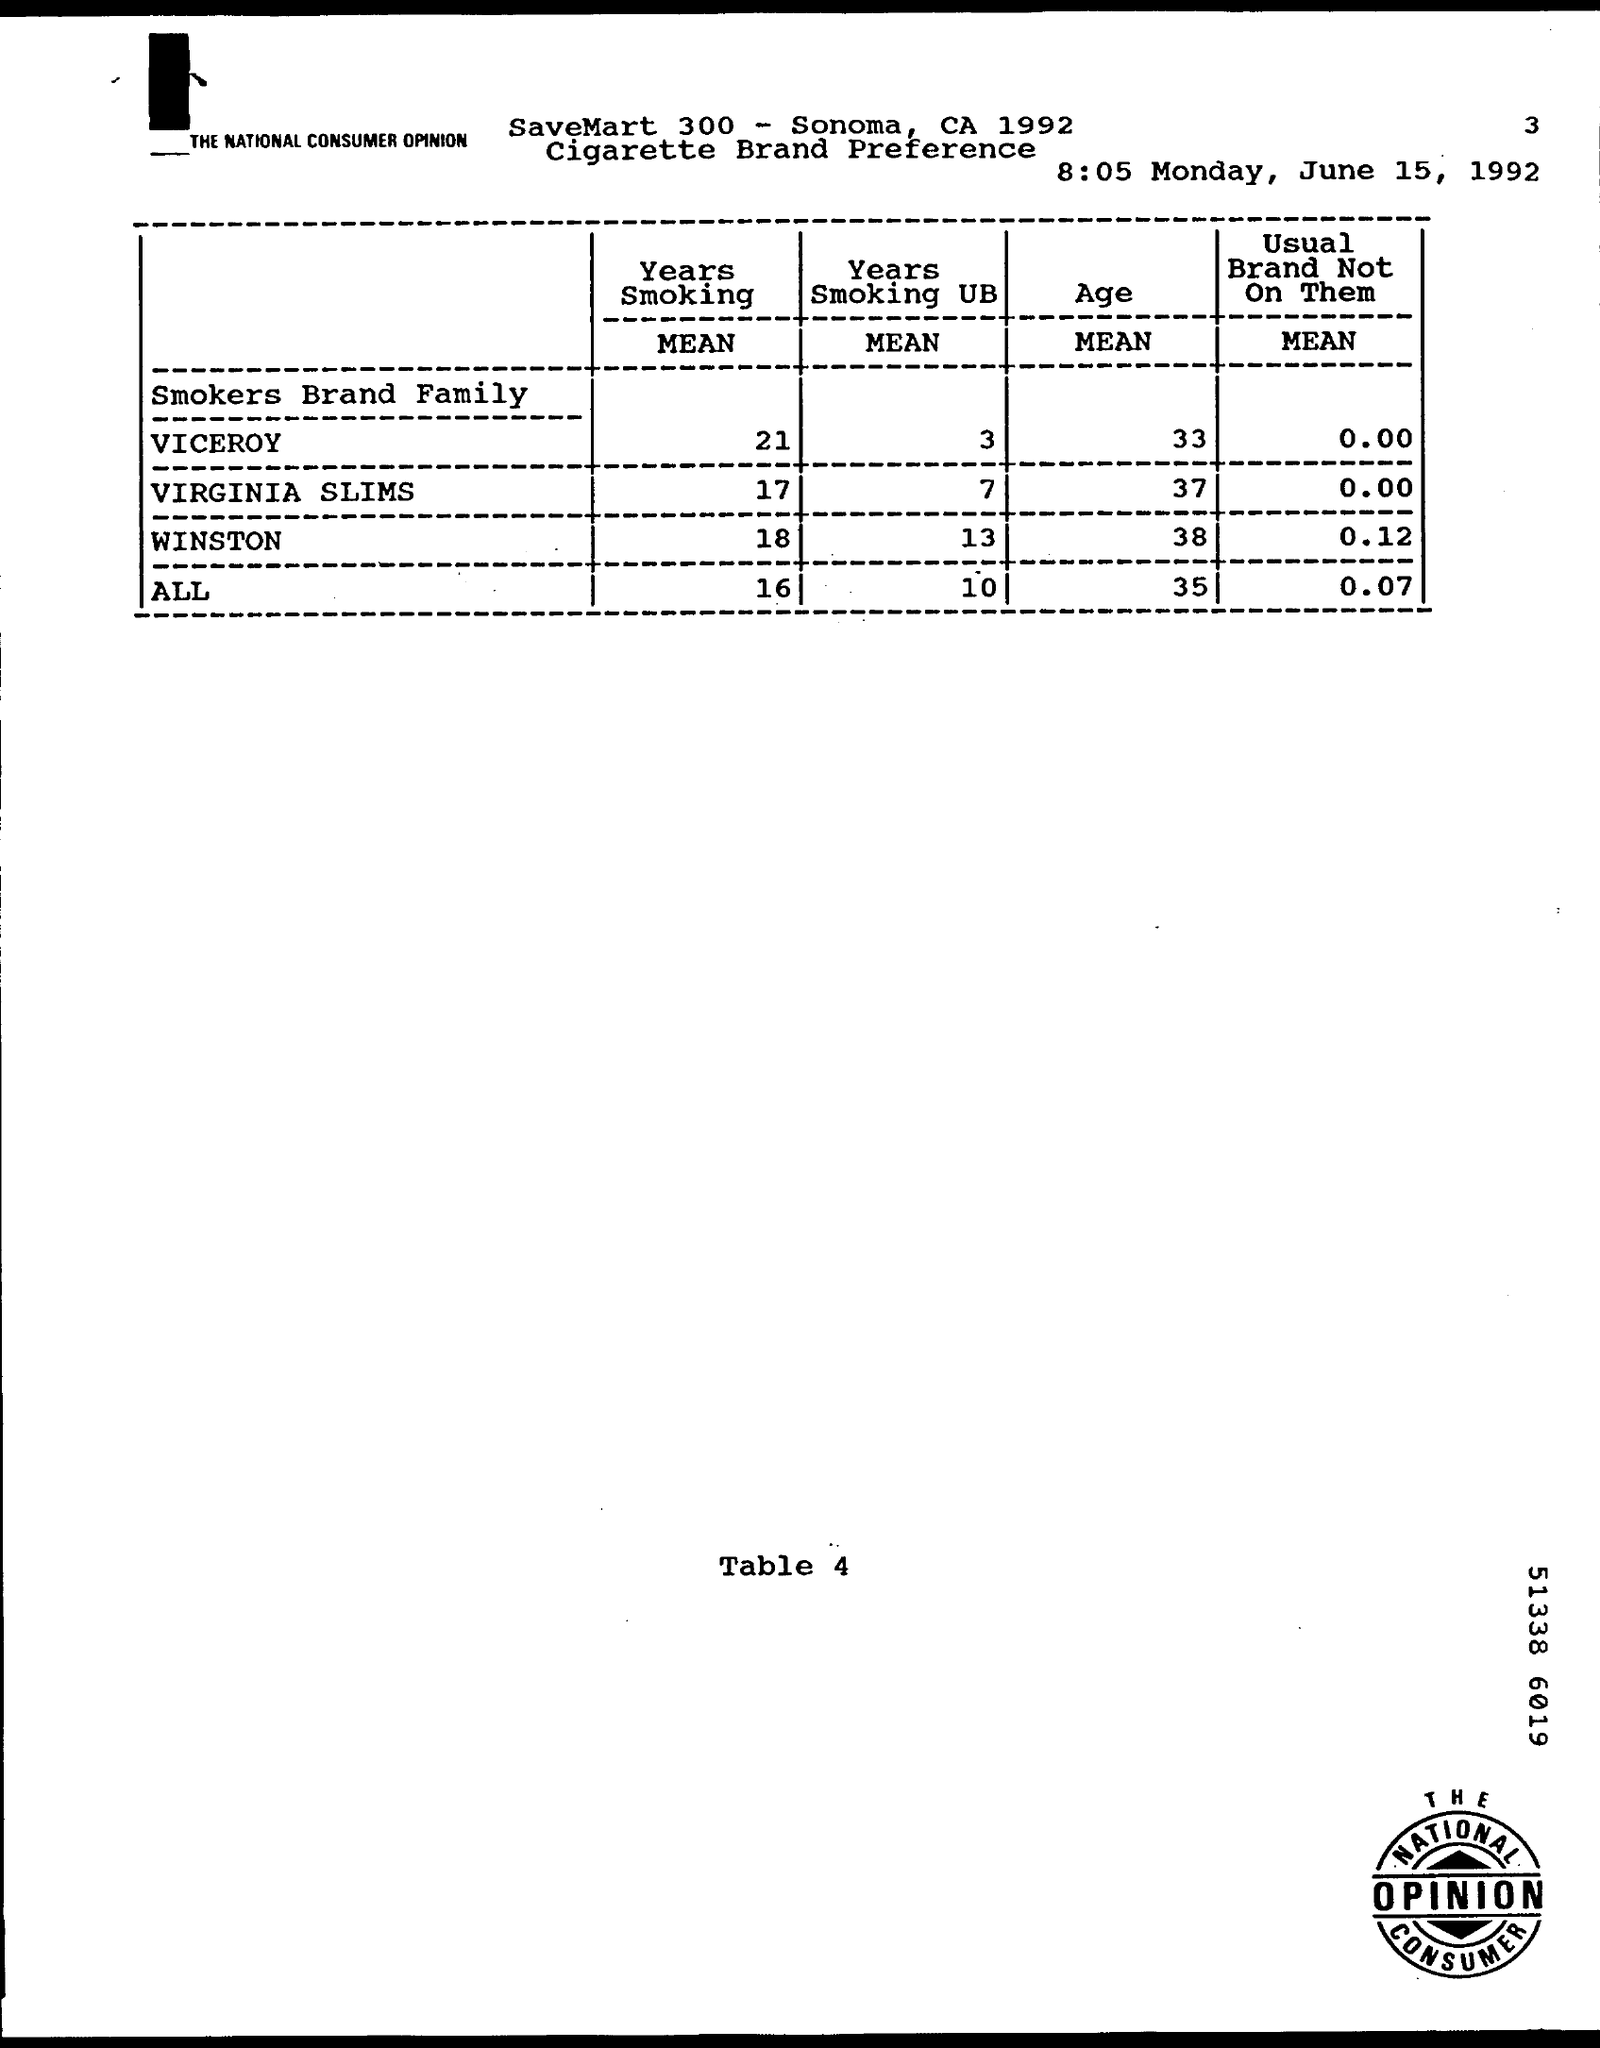List a handful of essential elements in this visual. The mean value of Viceroy Smokers brand family in the years of smoking was 21. The mean age of individuals in the Winston smokers brand family is approximately 38 years old. The average value of Virginia Slims cigarettes smoked in the years before 1975 is unknown. The mean age of all smokers in the Brand Family is 35. The mean value of all smokers who are part of the Brand Family is 0.07, while those who are not part of the Brand Family is not known. 